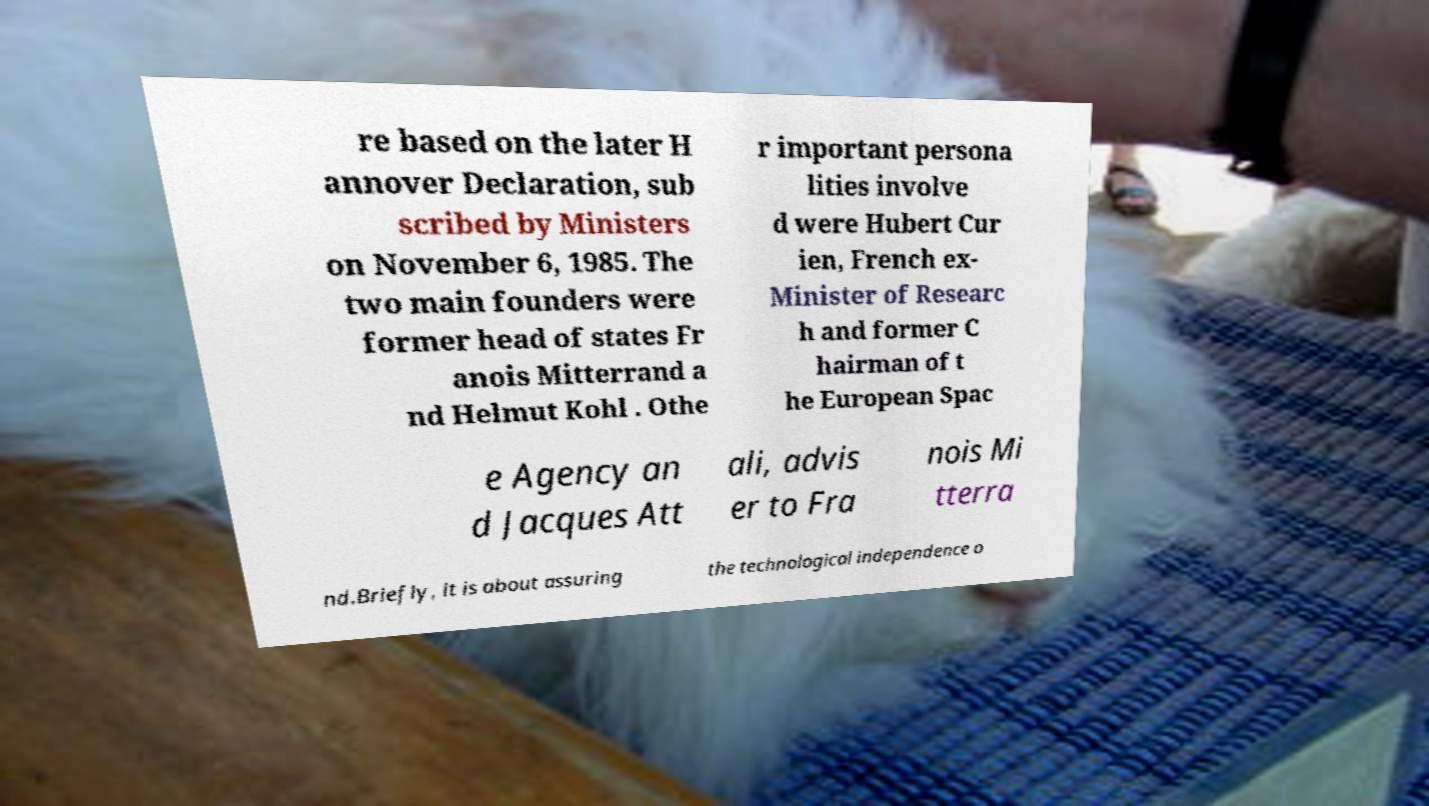Could you extract and type out the text from this image? re based on the later H annover Declaration, sub scribed by Ministers on November 6, 1985. The two main founders were former head of states Fr anois Mitterrand a nd Helmut Kohl . Othe r important persona lities involve d were Hubert Cur ien, French ex- Minister of Researc h and former C hairman of t he European Spac e Agency an d Jacques Att ali, advis er to Fra nois Mi tterra nd.Briefly, it is about assuring the technological independence o 